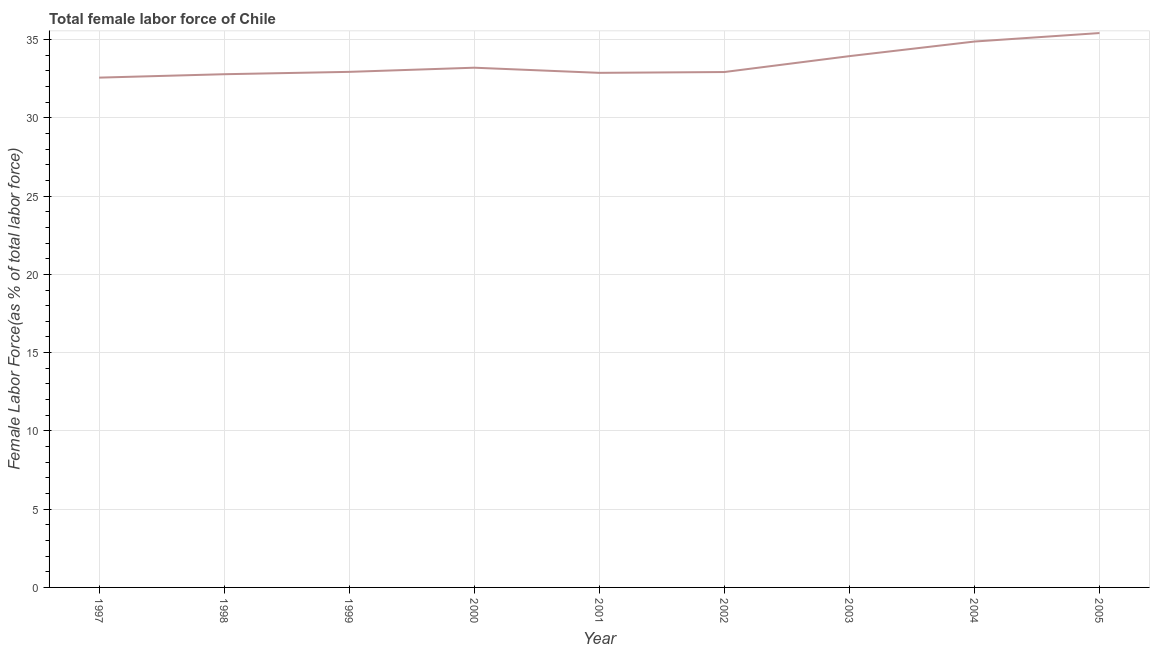What is the total female labor force in 1997?
Your response must be concise. 32.57. Across all years, what is the maximum total female labor force?
Your answer should be very brief. 35.41. Across all years, what is the minimum total female labor force?
Ensure brevity in your answer.  32.57. What is the sum of the total female labor force?
Offer a terse response. 301.52. What is the difference between the total female labor force in 1997 and 2005?
Provide a succinct answer. -2.85. What is the average total female labor force per year?
Keep it short and to the point. 33.5. What is the median total female labor force?
Offer a terse response. 32.94. In how many years, is the total female labor force greater than 15 %?
Your answer should be very brief. 9. Do a majority of the years between 1999 and 2004 (inclusive) have total female labor force greater than 26 %?
Make the answer very short. Yes. What is the ratio of the total female labor force in 1998 to that in 2000?
Ensure brevity in your answer.  0.99. Is the difference between the total female labor force in 1999 and 2004 greater than the difference between any two years?
Your answer should be compact. No. What is the difference between the highest and the second highest total female labor force?
Your answer should be compact. 0.54. What is the difference between the highest and the lowest total female labor force?
Your answer should be compact. 2.85. In how many years, is the total female labor force greater than the average total female labor force taken over all years?
Give a very brief answer. 3. Does the total female labor force monotonically increase over the years?
Ensure brevity in your answer.  No. What is the difference between two consecutive major ticks on the Y-axis?
Give a very brief answer. 5. Does the graph contain grids?
Ensure brevity in your answer.  Yes. What is the title of the graph?
Provide a short and direct response. Total female labor force of Chile. What is the label or title of the X-axis?
Your answer should be compact. Year. What is the label or title of the Y-axis?
Keep it short and to the point. Female Labor Force(as % of total labor force). What is the Female Labor Force(as % of total labor force) in 1997?
Your response must be concise. 32.57. What is the Female Labor Force(as % of total labor force) of 1998?
Your response must be concise. 32.79. What is the Female Labor Force(as % of total labor force) in 1999?
Offer a terse response. 32.94. What is the Female Labor Force(as % of total labor force) in 2000?
Your response must be concise. 33.2. What is the Female Labor Force(as % of total labor force) of 2001?
Offer a terse response. 32.87. What is the Female Labor Force(as % of total labor force) in 2002?
Your response must be concise. 32.92. What is the Female Labor Force(as % of total labor force) of 2003?
Offer a very short reply. 33.94. What is the Female Labor Force(as % of total labor force) in 2004?
Keep it short and to the point. 34.87. What is the Female Labor Force(as % of total labor force) of 2005?
Offer a very short reply. 35.41. What is the difference between the Female Labor Force(as % of total labor force) in 1997 and 1998?
Give a very brief answer. -0.22. What is the difference between the Female Labor Force(as % of total labor force) in 1997 and 1999?
Offer a terse response. -0.37. What is the difference between the Female Labor Force(as % of total labor force) in 1997 and 2000?
Ensure brevity in your answer.  -0.63. What is the difference between the Female Labor Force(as % of total labor force) in 1997 and 2001?
Keep it short and to the point. -0.31. What is the difference between the Female Labor Force(as % of total labor force) in 1997 and 2002?
Offer a terse response. -0.36. What is the difference between the Female Labor Force(as % of total labor force) in 1997 and 2003?
Offer a very short reply. -1.37. What is the difference between the Female Labor Force(as % of total labor force) in 1997 and 2004?
Provide a short and direct response. -2.31. What is the difference between the Female Labor Force(as % of total labor force) in 1997 and 2005?
Your answer should be very brief. -2.85. What is the difference between the Female Labor Force(as % of total labor force) in 1998 and 1999?
Offer a very short reply. -0.15. What is the difference between the Female Labor Force(as % of total labor force) in 1998 and 2000?
Provide a short and direct response. -0.42. What is the difference between the Female Labor Force(as % of total labor force) in 1998 and 2001?
Offer a very short reply. -0.09. What is the difference between the Female Labor Force(as % of total labor force) in 1998 and 2002?
Your answer should be very brief. -0.14. What is the difference between the Female Labor Force(as % of total labor force) in 1998 and 2003?
Keep it short and to the point. -1.16. What is the difference between the Female Labor Force(as % of total labor force) in 1998 and 2004?
Keep it short and to the point. -2.09. What is the difference between the Female Labor Force(as % of total labor force) in 1998 and 2005?
Your answer should be compact. -2.63. What is the difference between the Female Labor Force(as % of total labor force) in 1999 and 2000?
Provide a short and direct response. -0.27. What is the difference between the Female Labor Force(as % of total labor force) in 1999 and 2001?
Ensure brevity in your answer.  0.06. What is the difference between the Female Labor Force(as % of total labor force) in 1999 and 2002?
Your response must be concise. 0.01. What is the difference between the Female Labor Force(as % of total labor force) in 1999 and 2003?
Make the answer very short. -1. What is the difference between the Female Labor Force(as % of total labor force) in 1999 and 2004?
Your answer should be very brief. -1.94. What is the difference between the Female Labor Force(as % of total labor force) in 1999 and 2005?
Your answer should be very brief. -2.48. What is the difference between the Female Labor Force(as % of total labor force) in 2000 and 2001?
Give a very brief answer. 0.33. What is the difference between the Female Labor Force(as % of total labor force) in 2000 and 2002?
Your answer should be very brief. 0.28. What is the difference between the Female Labor Force(as % of total labor force) in 2000 and 2003?
Ensure brevity in your answer.  -0.74. What is the difference between the Female Labor Force(as % of total labor force) in 2000 and 2004?
Your answer should be very brief. -1.67. What is the difference between the Female Labor Force(as % of total labor force) in 2000 and 2005?
Provide a short and direct response. -2.21. What is the difference between the Female Labor Force(as % of total labor force) in 2001 and 2002?
Ensure brevity in your answer.  -0.05. What is the difference between the Female Labor Force(as % of total labor force) in 2001 and 2003?
Keep it short and to the point. -1.07. What is the difference between the Female Labor Force(as % of total labor force) in 2001 and 2004?
Give a very brief answer. -2. What is the difference between the Female Labor Force(as % of total labor force) in 2001 and 2005?
Offer a very short reply. -2.54. What is the difference between the Female Labor Force(as % of total labor force) in 2002 and 2003?
Provide a succinct answer. -1.02. What is the difference between the Female Labor Force(as % of total labor force) in 2002 and 2004?
Your response must be concise. -1.95. What is the difference between the Female Labor Force(as % of total labor force) in 2002 and 2005?
Ensure brevity in your answer.  -2.49. What is the difference between the Female Labor Force(as % of total labor force) in 2003 and 2004?
Your answer should be compact. -0.93. What is the difference between the Female Labor Force(as % of total labor force) in 2003 and 2005?
Provide a succinct answer. -1.47. What is the difference between the Female Labor Force(as % of total labor force) in 2004 and 2005?
Your response must be concise. -0.54. What is the ratio of the Female Labor Force(as % of total labor force) in 1997 to that in 1999?
Provide a succinct answer. 0.99. What is the ratio of the Female Labor Force(as % of total labor force) in 1997 to that in 2000?
Your answer should be very brief. 0.98. What is the ratio of the Female Labor Force(as % of total labor force) in 1997 to that in 2002?
Provide a short and direct response. 0.99. What is the ratio of the Female Labor Force(as % of total labor force) in 1997 to that in 2004?
Your answer should be compact. 0.93. What is the ratio of the Female Labor Force(as % of total labor force) in 1998 to that in 1999?
Offer a terse response. 0.99. What is the ratio of the Female Labor Force(as % of total labor force) in 1998 to that in 2002?
Your answer should be very brief. 1. What is the ratio of the Female Labor Force(as % of total labor force) in 1998 to that in 2003?
Your response must be concise. 0.97. What is the ratio of the Female Labor Force(as % of total labor force) in 1998 to that in 2004?
Offer a terse response. 0.94. What is the ratio of the Female Labor Force(as % of total labor force) in 1998 to that in 2005?
Keep it short and to the point. 0.93. What is the ratio of the Female Labor Force(as % of total labor force) in 1999 to that in 2000?
Provide a succinct answer. 0.99. What is the ratio of the Female Labor Force(as % of total labor force) in 1999 to that in 2001?
Make the answer very short. 1. What is the ratio of the Female Labor Force(as % of total labor force) in 1999 to that in 2004?
Ensure brevity in your answer.  0.94. What is the ratio of the Female Labor Force(as % of total labor force) in 1999 to that in 2005?
Keep it short and to the point. 0.93. What is the ratio of the Female Labor Force(as % of total labor force) in 2000 to that in 2001?
Give a very brief answer. 1.01. What is the ratio of the Female Labor Force(as % of total labor force) in 2000 to that in 2002?
Offer a terse response. 1.01. What is the ratio of the Female Labor Force(as % of total labor force) in 2000 to that in 2004?
Keep it short and to the point. 0.95. What is the ratio of the Female Labor Force(as % of total labor force) in 2000 to that in 2005?
Provide a succinct answer. 0.94. What is the ratio of the Female Labor Force(as % of total labor force) in 2001 to that in 2002?
Make the answer very short. 1. What is the ratio of the Female Labor Force(as % of total labor force) in 2001 to that in 2003?
Your answer should be very brief. 0.97. What is the ratio of the Female Labor Force(as % of total labor force) in 2001 to that in 2004?
Make the answer very short. 0.94. What is the ratio of the Female Labor Force(as % of total labor force) in 2001 to that in 2005?
Ensure brevity in your answer.  0.93. What is the ratio of the Female Labor Force(as % of total labor force) in 2002 to that in 2003?
Your answer should be compact. 0.97. What is the ratio of the Female Labor Force(as % of total labor force) in 2002 to that in 2004?
Your response must be concise. 0.94. What is the ratio of the Female Labor Force(as % of total labor force) in 2003 to that in 2004?
Offer a very short reply. 0.97. What is the ratio of the Female Labor Force(as % of total labor force) in 2003 to that in 2005?
Keep it short and to the point. 0.96. 